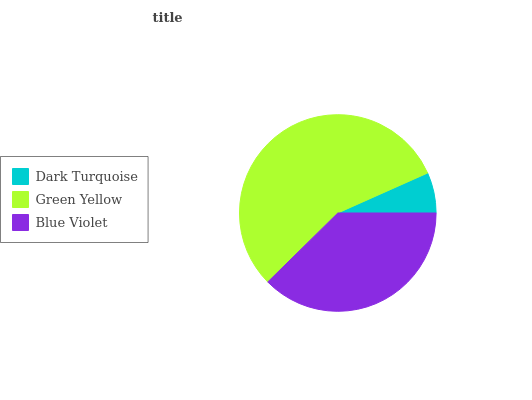Is Dark Turquoise the minimum?
Answer yes or no. Yes. Is Green Yellow the maximum?
Answer yes or no. Yes. Is Blue Violet the minimum?
Answer yes or no. No. Is Blue Violet the maximum?
Answer yes or no. No. Is Green Yellow greater than Blue Violet?
Answer yes or no. Yes. Is Blue Violet less than Green Yellow?
Answer yes or no. Yes. Is Blue Violet greater than Green Yellow?
Answer yes or no. No. Is Green Yellow less than Blue Violet?
Answer yes or no. No. Is Blue Violet the high median?
Answer yes or no. Yes. Is Blue Violet the low median?
Answer yes or no. Yes. Is Dark Turquoise the high median?
Answer yes or no. No. Is Dark Turquoise the low median?
Answer yes or no. No. 